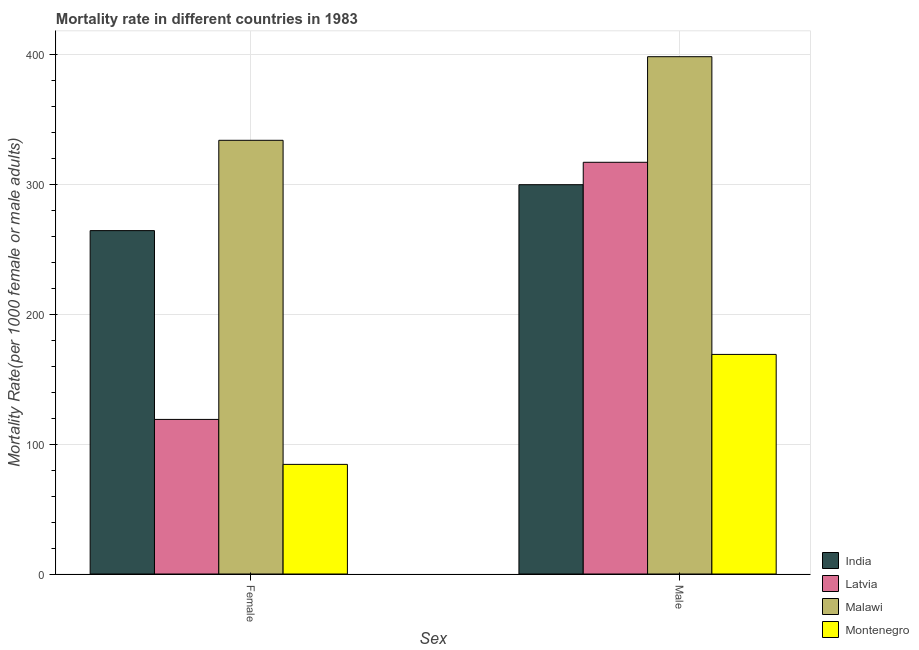How many different coloured bars are there?
Give a very brief answer. 4. How many groups of bars are there?
Ensure brevity in your answer.  2. How many bars are there on the 2nd tick from the left?
Ensure brevity in your answer.  4. What is the male mortality rate in Latvia?
Ensure brevity in your answer.  317.03. Across all countries, what is the maximum female mortality rate?
Your answer should be very brief. 333.96. Across all countries, what is the minimum male mortality rate?
Provide a short and direct response. 169.09. In which country was the female mortality rate maximum?
Keep it short and to the point. Malawi. In which country was the male mortality rate minimum?
Keep it short and to the point. Montenegro. What is the total male mortality rate in the graph?
Make the answer very short. 1184.26. What is the difference between the male mortality rate in Malawi and that in Latvia?
Your answer should be compact. 81.32. What is the difference between the female mortality rate in Malawi and the male mortality rate in Latvia?
Offer a very short reply. 16.93. What is the average female mortality rate per country?
Offer a terse response. 200.46. What is the difference between the female mortality rate and male mortality rate in Latvia?
Give a very brief answer. -198. In how many countries, is the female mortality rate greater than 80 ?
Your answer should be very brief. 4. What is the ratio of the female mortality rate in India to that in Latvia?
Make the answer very short. 2.22. What does the 2nd bar from the left in Female represents?
Your response must be concise. Latvia. What does the 2nd bar from the right in Male represents?
Your response must be concise. Malawi. How many bars are there?
Your response must be concise. 8. Are all the bars in the graph horizontal?
Your response must be concise. No. Are the values on the major ticks of Y-axis written in scientific E-notation?
Ensure brevity in your answer.  No. Does the graph contain any zero values?
Make the answer very short. No. Does the graph contain grids?
Provide a succinct answer. Yes. How are the legend labels stacked?
Provide a succinct answer. Vertical. What is the title of the graph?
Offer a terse response. Mortality rate in different countries in 1983. Does "Latin America(all income levels)" appear as one of the legend labels in the graph?
Keep it short and to the point. No. What is the label or title of the X-axis?
Provide a short and direct response. Sex. What is the label or title of the Y-axis?
Provide a short and direct response. Mortality Rate(per 1000 female or male adults). What is the Mortality Rate(per 1000 female or male adults) in India in Female?
Your response must be concise. 264.42. What is the Mortality Rate(per 1000 female or male adults) in Latvia in Female?
Provide a succinct answer. 119.04. What is the Mortality Rate(per 1000 female or male adults) in Malawi in Female?
Provide a short and direct response. 333.96. What is the Mortality Rate(per 1000 female or male adults) of Montenegro in Female?
Provide a short and direct response. 84.42. What is the Mortality Rate(per 1000 female or male adults) in India in Male?
Your answer should be very brief. 299.78. What is the Mortality Rate(per 1000 female or male adults) in Latvia in Male?
Offer a very short reply. 317.03. What is the Mortality Rate(per 1000 female or male adults) of Malawi in Male?
Your answer should be compact. 398.35. What is the Mortality Rate(per 1000 female or male adults) of Montenegro in Male?
Provide a succinct answer. 169.09. Across all Sex, what is the maximum Mortality Rate(per 1000 female or male adults) of India?
Your answer should be very brief. 299.78. Across all Sex, what is the maximum Mortality Rate(per 1000 female or male adults) in Latvia?
Your response must be concise. 317.03. Across all Sex, what is the maximum Mortality Rate(per 1000 female or male adults) in Malawi?
Ensure brevity in your answer.  398.35. Across all Sex, what is the maximum Mortality Rate(per 1000 female or male adults) of Montenegro?
Ensure brevity in your answer.  169.09. Across all Sex, what is the minimum Mortality Rate(per 1000 female or male adults) in India?
Provide a short and direct response. 264.42. Across all Sex, what is the minimum Mortality Rate(per 1000 female or male adults) in Latvia?
Provide a succinct answer. 119.04. Across all Sex, what is the minimum Mortality Rate(per 1000 female or male adults) in Malawi?
Your answer should be very brief. 333.96. Across all Sex, what is the minimum Mortality Rate(per 1000 female or male adults) of Montenegro?
Give a very brief answer. 84.42. What is the total Mortality Rate(per 1000 female or male adults) of India in the graph?
Ensure brevity in your answer.  564.2. What is the total Mortality Rate(per 1000 female or male adults) of Latvia in the graph?
Give a very brief answer. 436.07. What is the total Mortality Rate(per 1000 female or male adults) of Malawi in the graph?
Offer a terse response. 732.31. What is the total Mortality Rate(per 1000 female or male adults) in Montenegro in the graph?
Provide a succinct answer. 253.51. What is the difference between the Mortality Rate(per 1000 female or male adults) in India in Female and that in Male?
Keep it short and to the point. -35.36. What is the difference between the Mortality Rate(per 1000 female or male adults) in Latvia in Female and that in Male?
Provide a short and direct response. -198. What is the difference between the Mortality Rate(per 1000 female or male adults) in Malawi in Female and that in Male?
Offer a very short reply. -64.39. What is the difference between the Mortality Rate(per 1000 female or male adults) of Montenegro in Female and that in Male?
Give a very brief answer. -84.68. What is the difference between the Mortality Rate(per 1000 female or male adults) in India in Female and the Mortality Rate(per 1000 female or male adults) in Latvia in Male?
Your answer should be compact. -52.61. What is the difference between the Mortality Rate(per 1000 female or male adults) of India in Female and the Mortality Rate(per 1000 female or male adults) of Malawi in Male?
Your answer should be very brief. -133.93. What is the difference between the Mortality Rate(per 1000 female or male adults) in India in Female and the Mortality Rate(per 1000 female or male adults) in Montenegro in Male?
Make the answer very short. 95.33. What is the difference between the Mortality Rate(per 1000 female or male adults) in Latvia in Female and the Mortality Rate(per 1000 female or male adults) in Malawi in Male?
Keep it short and to the point. -279.31. What is the difference between the Mortality Rate(per 1000 female or male adults) of Latvia in Female and the Mortality Rate(per 1000 female or male adults) of Montenegro in Male?
Provide a succinct answer. -50.06. What is the difference between the Mortality Rate(per 1000 female or male adults) in Malawi in Female and the Mortality Rate(per 1000 female or male adults) in Montenegro in Male?
Offer a very short reply. 164.87. What is the average Mortality Rate(per 1000 female or male adults) in India per Sex?
Ensure brevity in your answer.  282.1. What is the average Mortality Rate(per 1000 female or male adults) of Latvia per Sex?
Offer a terse response. 218.03. What is the average Mortality Rate(per 1000 female or male adults) of Malawi per Sex?
Offer a very short reply. 366.16. What is the average Mortality Rate(per 1000 female or male adults) in Montenegro per Sex?
Offer a terse response. 126.76. What is the difference between the Mortality Rate(per 1000 female or male adults) of India and Mortality Rate(per 1000 female or male adults) of Latvia in Female?
Ensure brevity in your answer.  145.38. What is the difference between the Mortality Rate(per 1000 female or male adults) in India and Mortality Rate(per 1000 female or male adults) in Malawi in Female?
Ensure brevity in your answer.  -69.54. What is the difference between the Mortality Rate(per 1000 female or male adults) of India and Mortality Rate(per 1000 female or male adults) of Montenegro in Female?
Make the answer very short. 180. What is the difference between the Mortality Rate(per 1000 female or male adults) of Latvia and Mortality Rate(per 1000 female or male adults) of Malawi in Female?
Provide a succinct answer. -214.93. What is the difference between the Mortality Rate(per 1000 female or male adults) in Latvia and Mortality Rate(per 1000 female or male adults) in Montenegro in Female?
Keep it short and to the point. 34.62. What is the difference between the Mortality Rate(per 1000 female or male adults) in Malawi and Mortality Rate(per 1000 female or male adults) in Montenegro in Female?
Your answer should be compact. 249.55. What is the difference between the Mortality Rate(per 1000 female or male adults) in India and Mortality Rate(per 1000 female or male adults) in Latvia in Male?
Offer a very short reply. -17.25. What is the difference between the Mortality Rate(per 1000 female or male adults) in India and Mortality Rate(per 1000 female or male adults) in Malawi in Male?
Give a very brief answer. -98.57. What is the difference between the Mortality Rate(per 1000 female or male adults) of India and Mortality Rate(per 1000 female or male adults) of Montenegro in Male?
Your answer should be very brief. 130.69. What is the difference between the Mortality Rate(per 1000 female or male adults) in Latvia and Mortality Rate(per 1000 female or male adults) in Malawi in Male?
Give a very brief answer. -81.32. What is the difference between the Mortality Rate(per 1000 female or male adults) in Latvia and Mortality Rate(per 1000 female or male adults) in Montenegro in Male?
Your answer should be compact. 147.94. What is the difference between the Mortality Rate(per 1000 female or male adults) in Malawi and Mortality Rate(per 1000 female or male adults) in Montenegro in Male?
Ensure brevity in your answer.  229.26. What is the ratio of the Mortality Rate(per 1000 female or male adults) of India in Female to that in Male?
Provide a short and direct response. 0.88. What is the ratio of the Mortality Rate(per 1000 female or male adults) of Latvia in Female to that in Male?
Your response must be concise. 0.38. What is the ratio of the Mortality Rate(per 1000 female or male adults) of Malawi in Female to that in Male?
Your answer should be compact. 0.84. What is the ratio of the Mortality Rate(per 1000 female or male adults) of Montenegro in Female to that in Male?
Offer a terse response. 0.5. What is the difference between the highest and the second highest Mortality Rate(per 1000 female or male adults) in India?
Your answer should be compact. 35.36. What is the difference between the highest and the second highest Mortality Rate(per 1000 female or male adults) in Latvia?
Your response must be concise. 198. What is the difference between the highest and the second highest Mortality Rate(per 1000 female or male adults) of Malawi?
Keep it short and to the point. 64.39. What is the difference between the highest and the second highest Mortality Rate(per 1000 female or male adults) of Montenegro?
Offer a terse response. 84.68. What is the difference between the highest and the lowest Mortality Rate(per 1000 female or male adults) of India?
Make the answer very short. 35.36. What is the difference between the highest and the lowest Mortality Rate(per 1000 female or male adults) in Latvia?
Your answer should be compact. 198. What is the difference between the highest and the lowest Mortality Rate(per 1000 female or male adults) in Malawi?
Your answer should be compact. 64.39. What is the difference between the highest and the lowest Mortality Rate(per 1000 female or male adults) in Montenegro?
Your answer should be very brief. 84.68. 